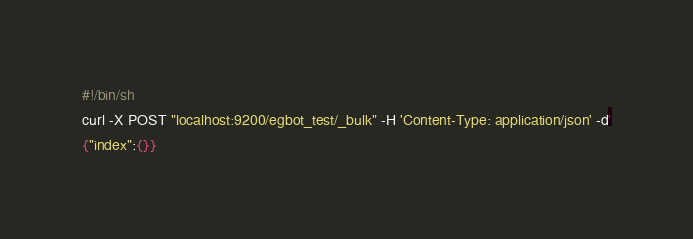<code> <loc_0><loc_0><loc_500><loc_500><_Bash_>#!/bin/sh
curl -X POST "localhost:9200/egbot_test/_bulk" -H 'Content-Type: application/json' -d'
{"index":{}}</code> 